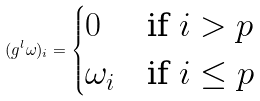<formula> <loc_0><loc_0><loc_500><loc_500>( g ^ { l } \omega ) _ { i } = \begin{cases} 0 & \text {if $i>p$} \\ \omega _ { i } & \text {if $i\leq p$} \end{cases}</formula> 